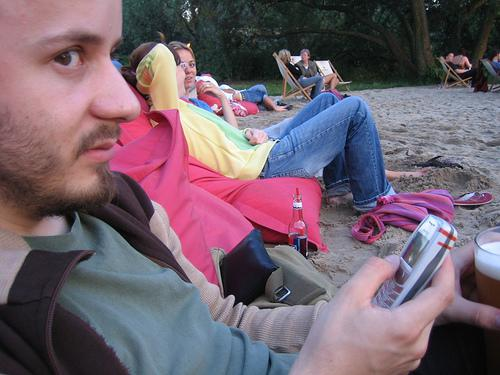Question: how was this picture lit?
Choices:
A. Natural light.
B. Flash.
C. Moon.
D. Sun.
Answer with the letter. Answer: A Question: what is behind the beach?
Choices:
A. Sand.
B. Island.
C. Water.
D. Woods.
Answer with the letter. Answer: D Question: what is the man in the front doing?
Choices:
A. Checking his phone.
B. Reading a book.
C. Eating a Twinkie.
D. Tying his shoes.
Answer with the letter. Answer: A Question: where was this picture taken?
Choices:
A. On a boat.
B. On a dock.
C. In front of a bar.
D. A beach.
Answer with the letter. Answer: D 